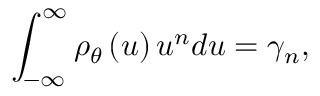Convert formula to latex. <formula><loc_0><loc_0><loc_500><loc_500>\int _ { - \infty } ^ { \infty } \rho _ { \theta } \left ( u \right ) u ^ { n } d u = \gamma _ { n } ,</formula> 